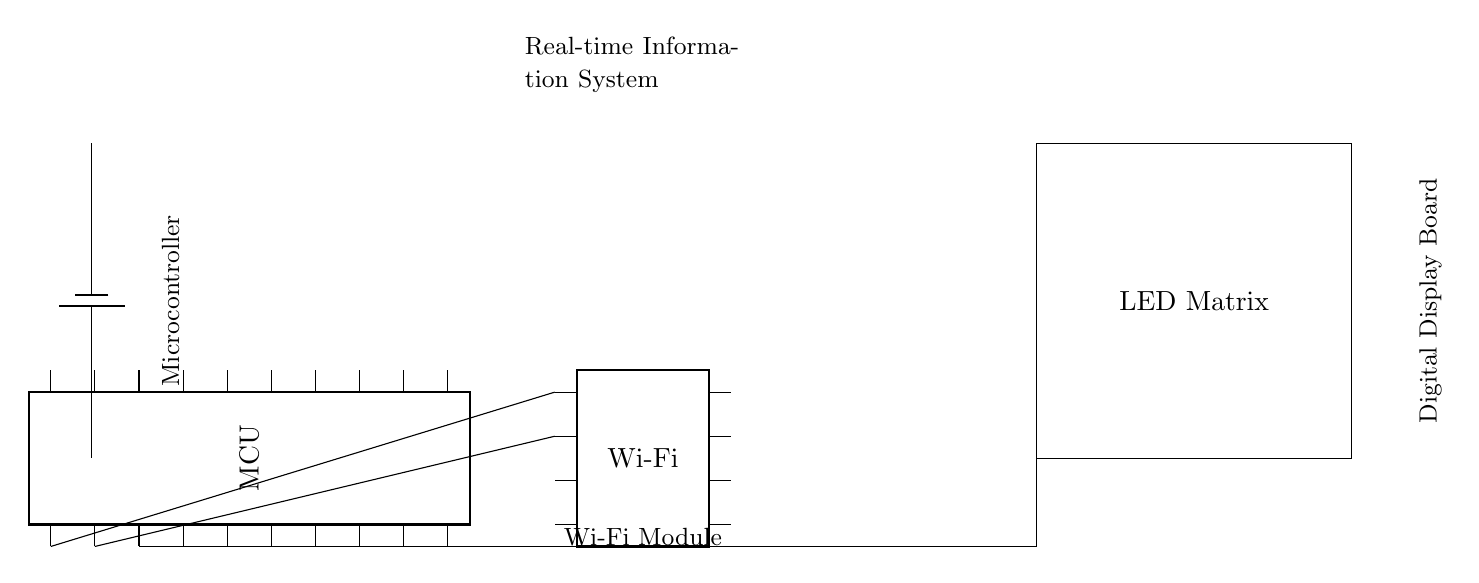What is the main component controlling the circuit? The main component is the microcontroller, which functions as the brain of the circuit, processing commands and coordinating actions.
Answer: microcontroller What type of display is used in the circuit? The display type used in the circuit is an LED matrix, which is indicated by the labeled rectangle in the diagram.
Answer: LED matrix How many pins does the Wi-Fi module have? The Wi-Fi module is shown to have 8 pins, which is derived from the visual representation of the component in the circuit diagram.
Answer: 8 What is the primary function of the Wi-Fi module in this circuit? The Wi-Fi module's primary function is to enable wireless communication, allowing the microcontroller to connect to the internet for real-time information retrieval.
Answer: wireless communication Which components are directly connected to the microcontroller? The components directly connected to the microcontroller are the Wi-Fi module and the LED matrix display, as seen from the lines drawn from the microcontroller to these two components.
Answer: Wi-Fi module and LED matrix What is the power source for this circuit? The power source for the circuit is indicated as a battery, providing necessary voltage to energize the components.
Answer: battery What does the label above the battery indicate about the circuit? The label above the battery indicates that this circuit is a real-time information system, suggesting its purpose of displaying up-to-date information at rallies.
Answer: real-time information system 